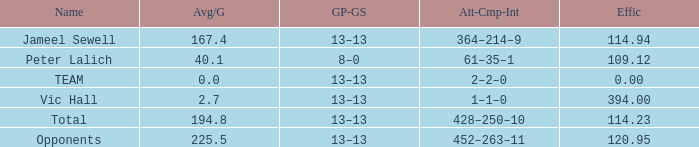Avg/G that has a GP-GS of 13–13, and a Effic smaller than 114.23 has what total of numbers? 1.0. 